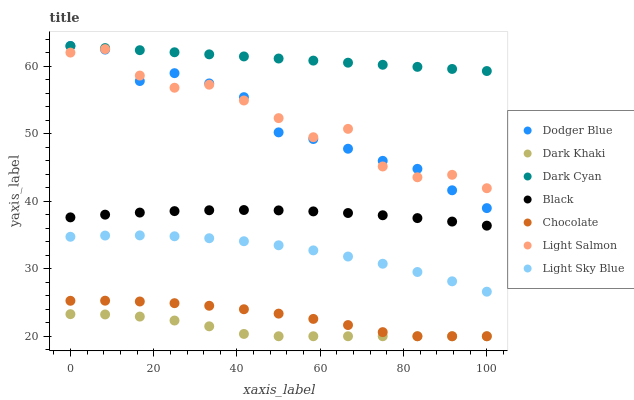Does Dark Khaki have the minimum area under the curve?
Answer yes or no. Yes. Does Dark Cyan have the maximum area under the curve?
Answer yes or no. Yes. Does Chocolate have the minimum area under the curve?
Answer yes or no. No. Does Chocolate have the maximum area under the curve?
Answer yes or no. No. Is Dark Cyan the smoothest?
Answer yes or no. Yes. Is Light Salmon the roughest?
Answer yes or no. Yes. Is Chocolate the smoothest?
Answer yes or no. No. Is Chocolate the roughest?
Answer yes or no. No. Does Chocolate have the lowest value?
Answer yes or no. Yes. Does Light Sky Blue have the lowest value?
Answer yes or no. No. Does Dark Cyan have the highest value?
Answer yes or no. Yes. Does Chocolate have the highest value?
Answer yes or no. No. Is Light Sky Blue less than Dark Cyan?
Answer yes or no. Yes. Is Dodger Blue greater than Black?
Answer yes or no. Yes. Does Dark Cyan intersect Dodger Blue?
Answer yes or no. Yes. Is Dark Cyan less than Dodger Blue?
Answer yes or no. No. Is Dark Cyan greater than Dodger Blue?
Answer yes or no. No. Does Light Sky Blue intersect Dark Cyan?
Answer yes or no. No. 